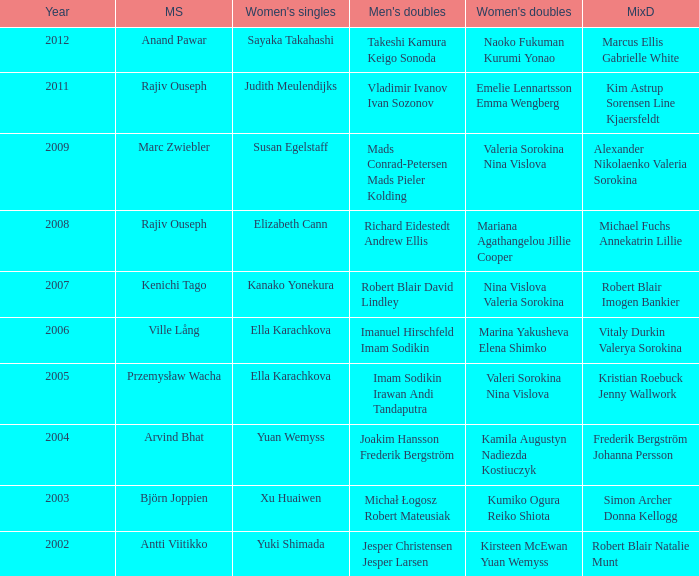Write the full table. {'header': ['Year', 'MS', "Women's singles", "Men's doubles", "Women's doubles", 'MixD'], 'rows': [['2012', 'Anand Pawar', 'Sayaka Takahashi', 'Takeshi Kamura Keigo Sonoda', 'Naoko Fukuman Kurumi Yonao', 'Marcus Ellis Gabrielle White'], ['2011', 'Rajiv Ouseph', 'Judith Meulendijks', 'Vladimir Ivanov Ivan Sozonov', 'Emelie Lennartsson Emma Wengberg', 'Kim Astrup Sorensen Line Kjaersfeldt'], ['2009', 'Marc Zwiebler', 'Susan Egelstaff', 'Mads Conrad-Petersen Mads Pieler Kolding', 'Valeria Sorokina Nina Vislova', 'Alexander Nikolaenko Valeria Sorokina'], ['2008', 'Rajiv Ouseph', 'Elizabeth Cann', 'Richard Eidestedt Andrew Ellis', 'Mariana Agathangelou Jillie Cooper', 'Michael Fuchs Annekatrin Lillie'], ['2007', 'Kenichi Tago', 'Kanako Yonekura', 'Robert Blair David Lindley', 'Nina Vislova Valeria Sorokina', 'Robert Blair Imogen Bankier'], ['2006', 'Ville Lång', 'Ella Karachkova', 'Imanuel Hirschfeld Imam Sodikin', 'Marina Yakusheva Elena Shimko', 'Vitaly Durkin Valerya Sorokina'], ['2005', 'Przemysław Wacha', 'Ella Karachkova', 'Imam Sodikin Irawan Andi Tandaputra', 'Valeri Sorokina Nina Vislova', 'Kristian Roebuck Jenny Wallwork'], ['2004', 'Arvind Bhat', 'Yuan Wemyss', 'Joakim Hansson Frederik Bergström', 'Kamila Augustyn Nadiezda Kostiuczyk', 'Frederik Bergström Johanna Persson'], ['2003', 'Björn Joppien', 'Xu Huaiwen', 'Michał Łogosz Robert Mateusiak', 'Kumiko Ogura Reiko Shiota', 'Simon Archer Donna Kellogg'], ['2002', 'Antti Viitikko', 'Yuki Shimada', 'Jesper Christensen Jesper Larsen', 'Kirsteen McEwan Yuan Wemyss', 'Robert Blair Natalie Munt']]} What is the womens singles of marcus ellis gabrielle white? Sayaka Takahashi. 